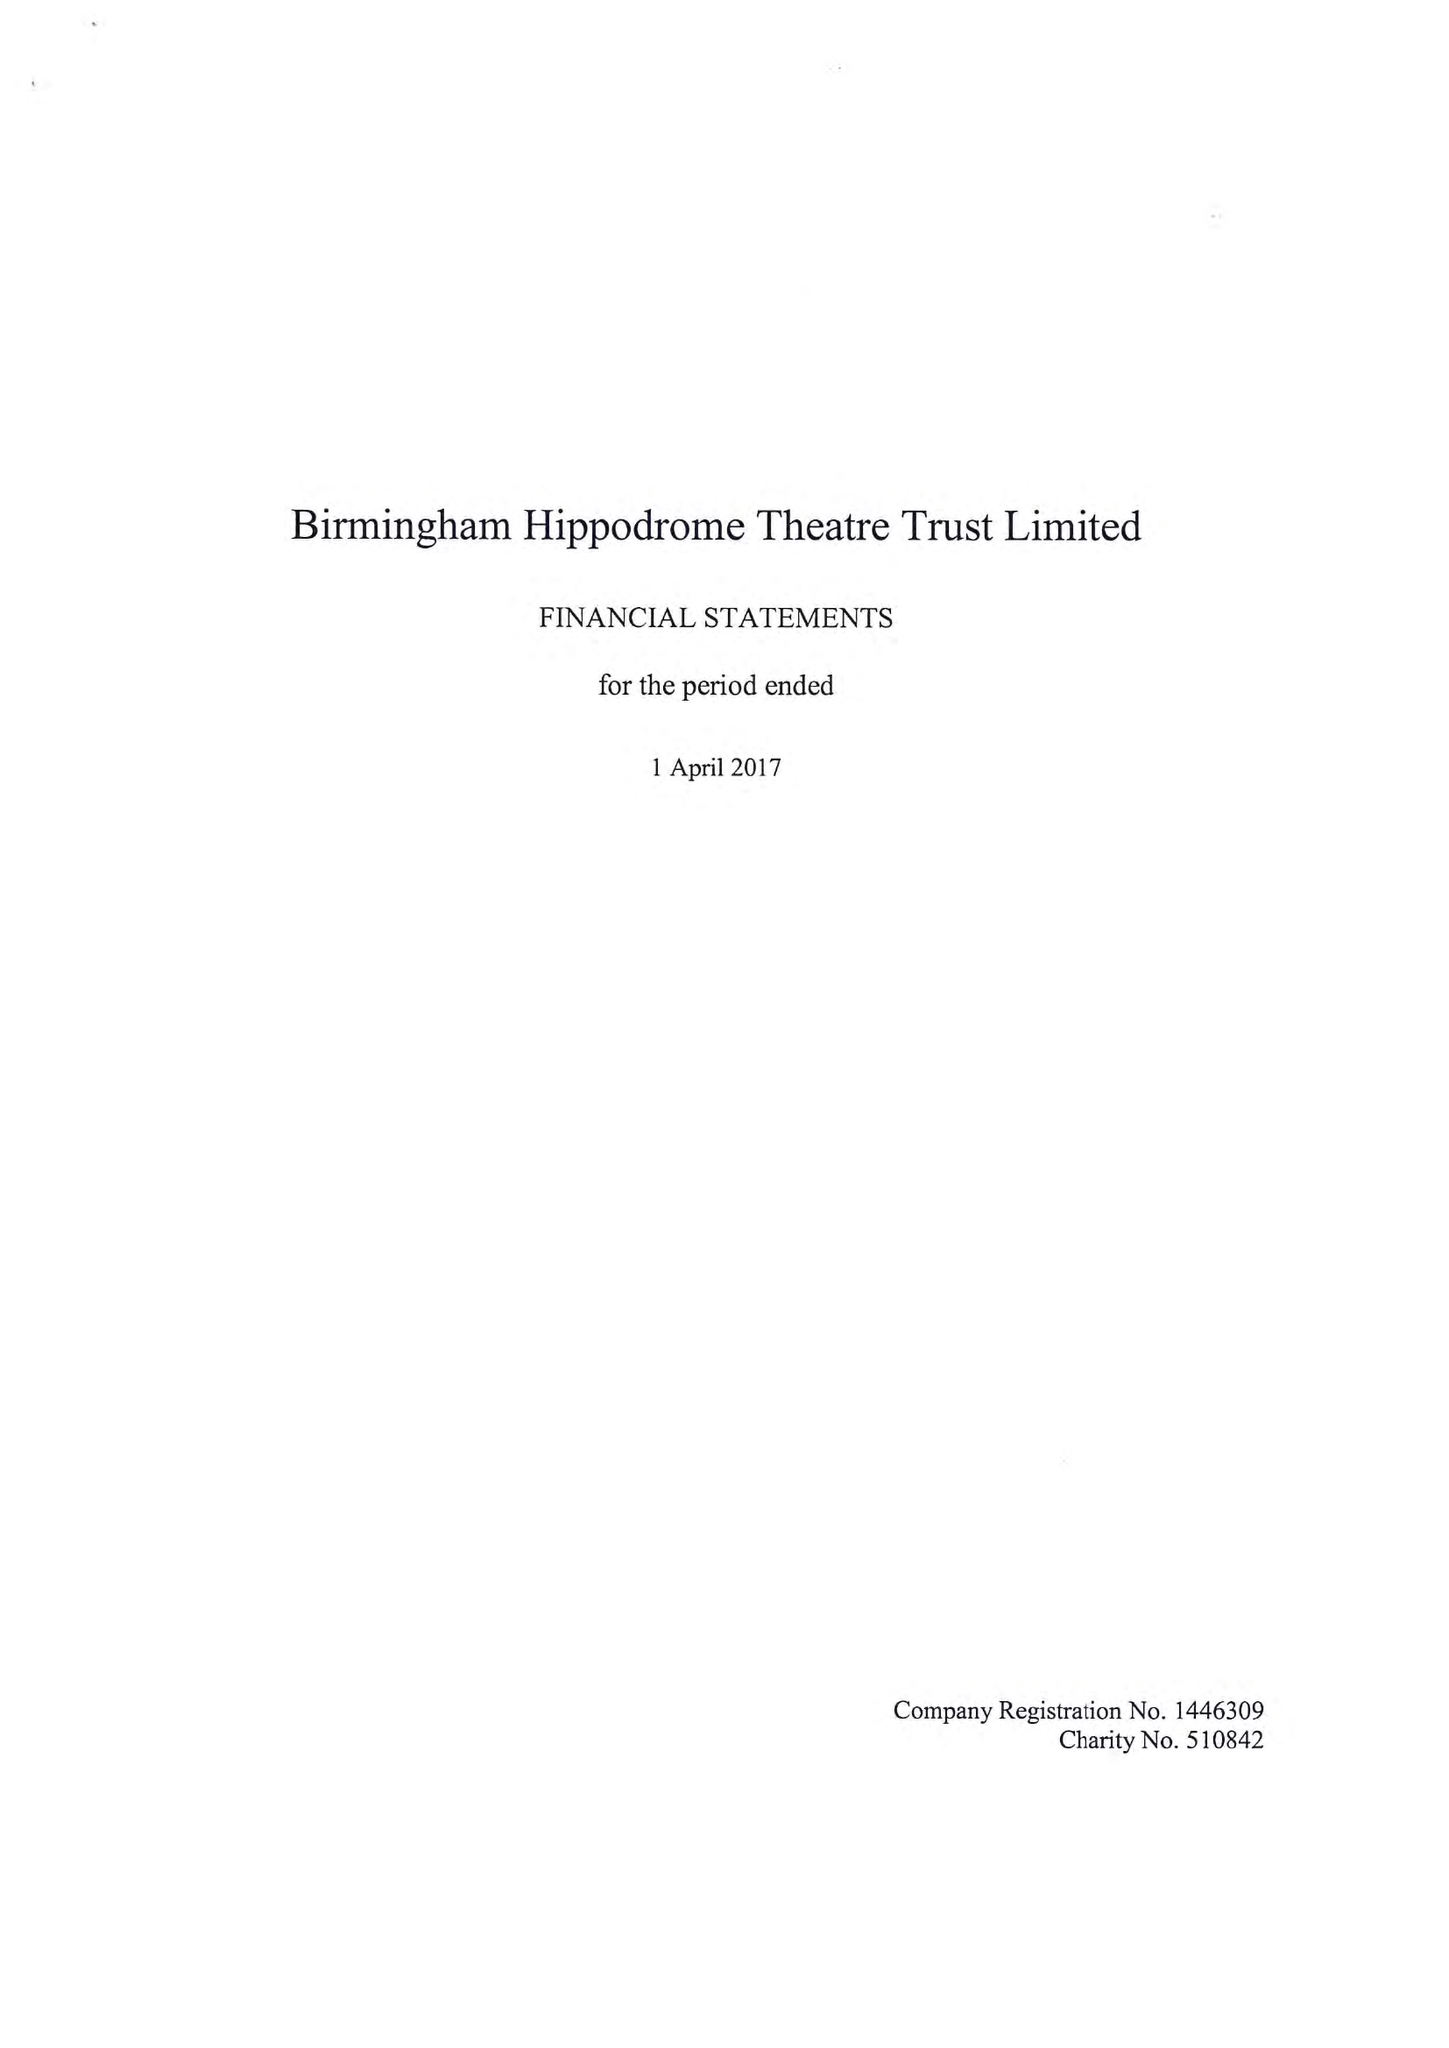What is the value for the income_annually_in_british_pounds?
Answer the question using a single word or phrase. 27772000.00 